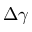Convert formula to latex. <formula><loc_0><loc_0><loc_500><loc_500>\Delta \gamma</formula> 